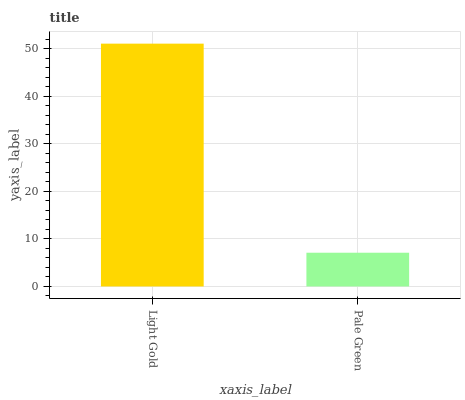Is Pale Green the minimum?
Answer yes or no. Yes. Is Light Gold the maximum?
Answer yes or no. Yes. Is Pale Green the maximum?
Answer yes or no. No. Is Light Gold greater than Pale Green?
Answer yes or no. Yes. Is Pale Green less than Light Gold?
Answer yes or no. Yes. Is Pale Green greater than Light Gold?
Answer yes or no. No. Is Light Gold less than Pale Green?
Answer yes or no. No. Is Light Gold the high median?
Answer yes or no. Yes. Is Pale Green the low median?
Answer yes or no. Yes. Is Pale Green the high median?
Answer yes or no. No. Is Light Gold the low median?
Answer yes or no. No. 